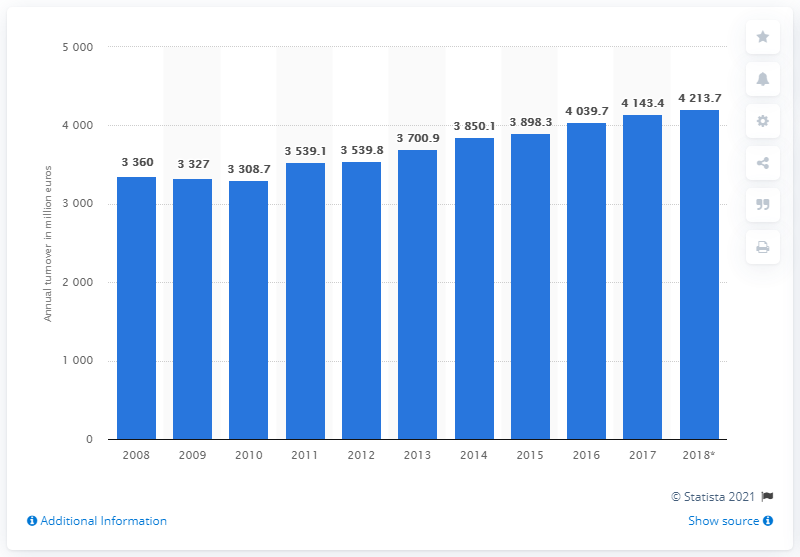Draw attention to some important aspects in this diagram. The total turnover of food, beverage, and tobacco stores in Austria in 2018 was 4,143.4 million euros. 